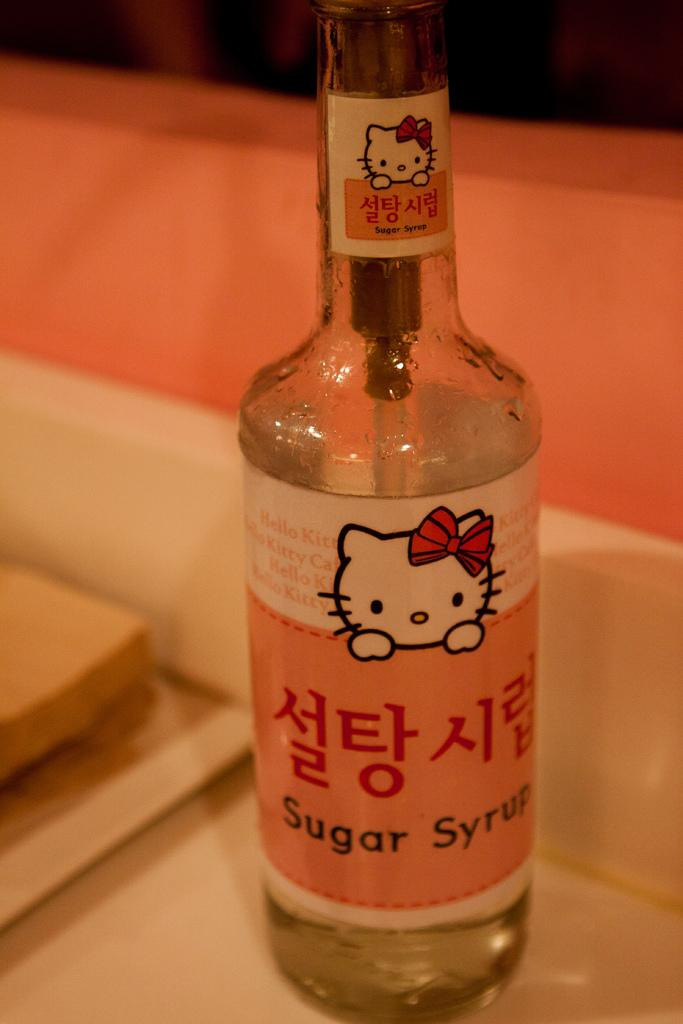<image>
Share a concise interpretation of the image provided. A bottle of hello kitty sugar syrup sits on a table 